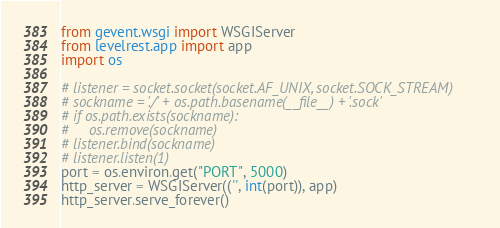Convert code to text. <code><loc_0><loc_0><loc_500><loc_500><_Python_>from gevent.wsgi import WSGIServer
from levelrest.app import app
import os

# listener = socket.socket(socket.AF_UNIX, socket.SOCK_STREAM)
# sockname = './' + os.path.basename(__file__) + '.sock'
# if os.path.exists(sockname):
#     os.remove(sockname)
# listener.bind(sockname)
# listener.listen(1)
port = os.environ.get("PORT", 5000)
http_server = WSGIServer(('', int(port)), app)
http_server.serve_forever()
</code> 